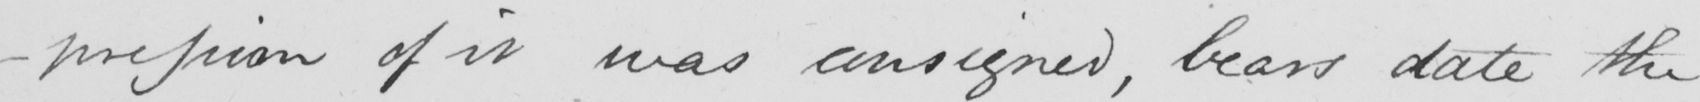Transcribe the text shown in this historical manuscript line. -pression of it was consigned , bears date the 